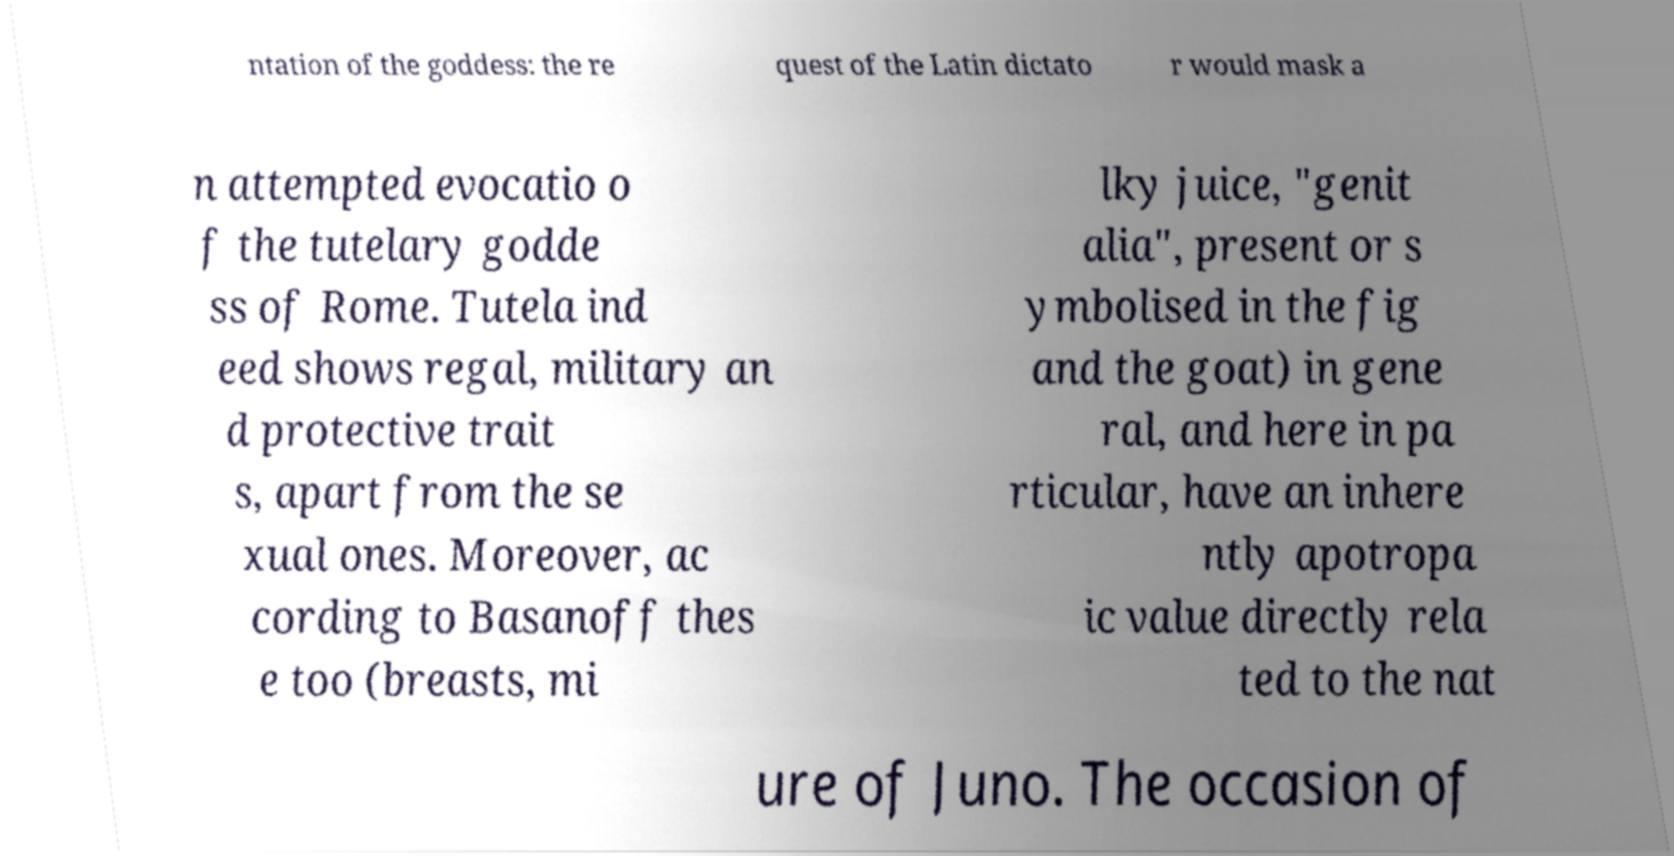Please read and relay the text visible in this image. What does it say? ntation of the goddess: the re quest of the Latin dictato r would mask a n attempted evocatio o f the tutelary godde ss of Rome. Tutela ind eed shows regal, military an d protective trait s, apart from the se xual ones. Moreover, ac cording to Basanoff thes e too (breasts, mi lky juice, "genit alia", present or s ymbolised in the fig and the goat) in gene ral, and here in pa rticular, have an inhere ntly apotropa ic value directly rela ted to the nat ure of Juno. The occasion of 